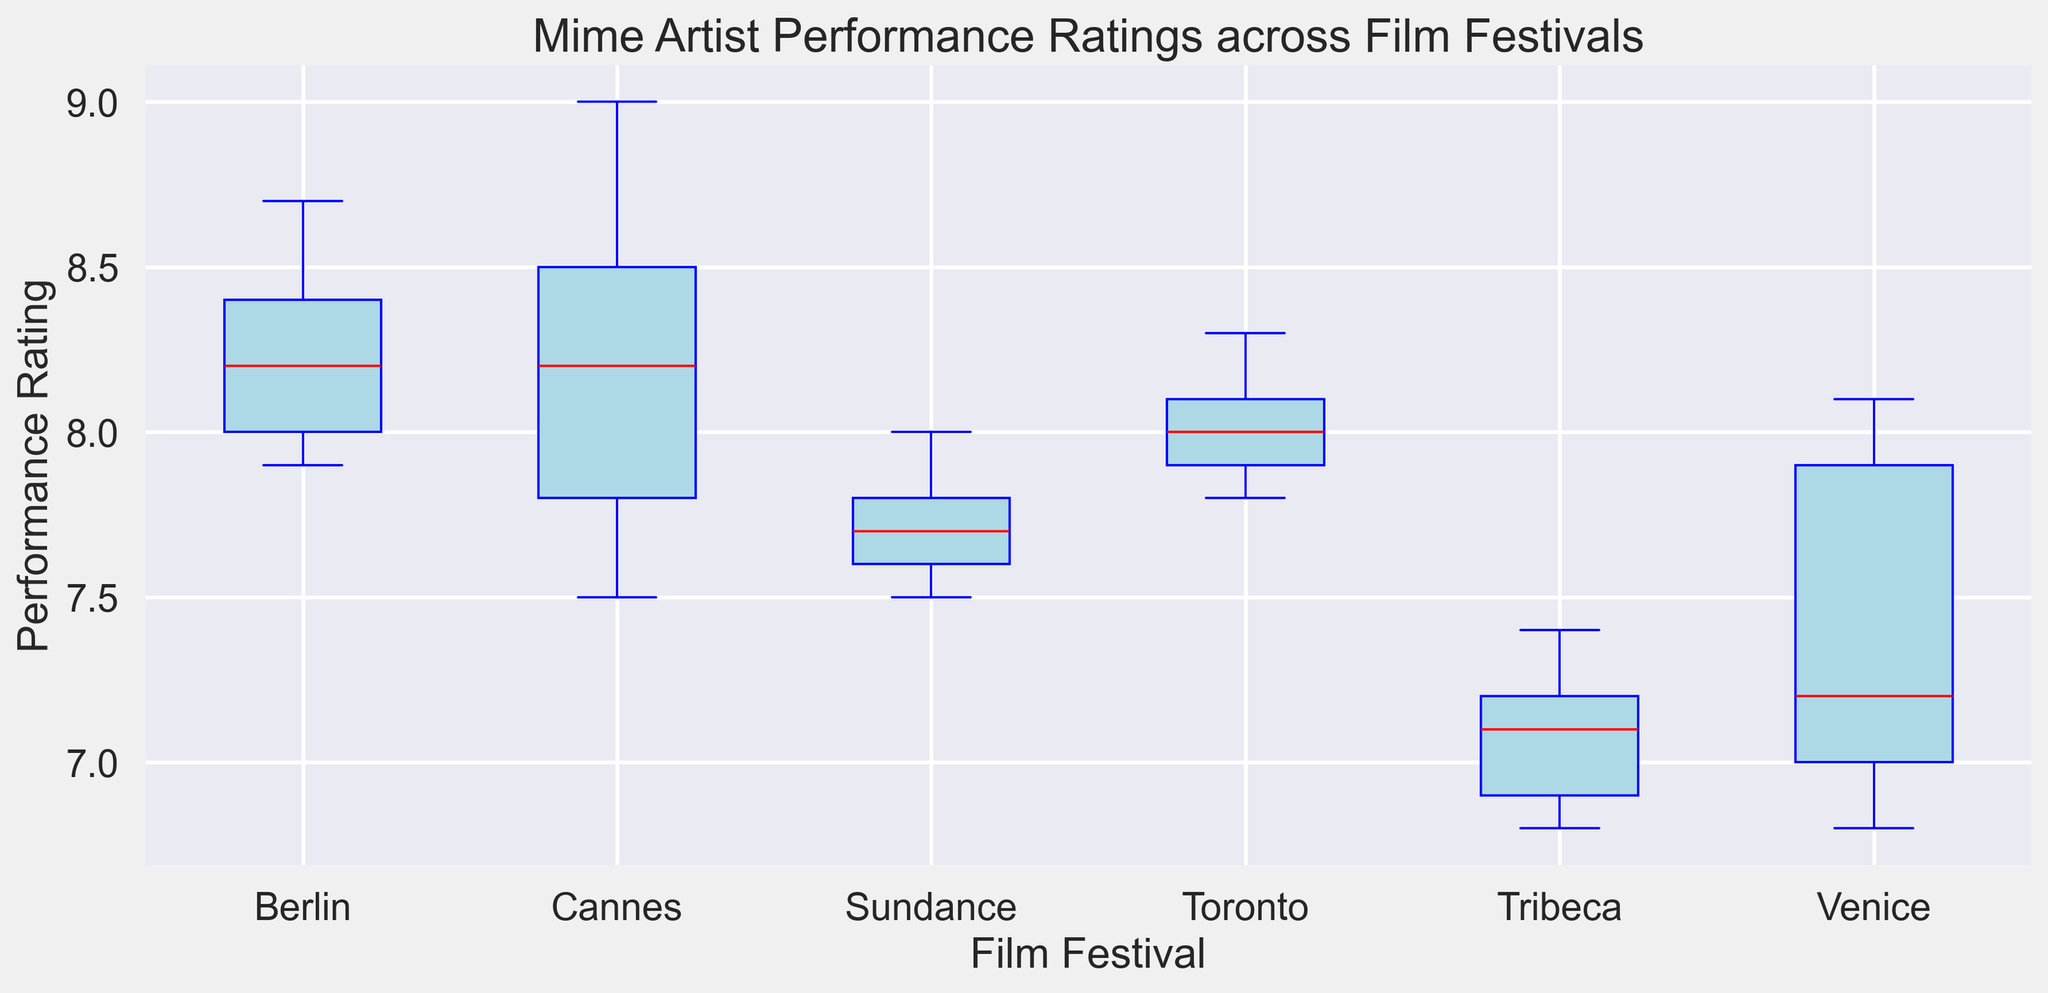What is the median Performance Rating at the Cannes Film Festival? Look at the box plot for the Cannes Film Festival and identify the median line (red) within the box.
Answer: 8.2 Which Film Festival has the highest median Performance Rating? Compare the median lines (red) for all the film festivals and identify the one with the highest position.
Answer: Cannes Which two Film Festivals have the greatest difference in their median Performance Ratings? Identify the median lines for all the festivals. Find the two with the highest and lowest medians and calculate their difference.
Answer: Cannes and Tribeca What is the range (difference between the maximum and minimum) of Performance Ratings at the Berlin Film Festival? Find the highest and lowest points (whiskers) for the Berlin Film Festival box plot, then compute their difference.
Answer: 8.7 - 7.9 = 0.8 Which Film Festival has the widest interquartile range (IQR, the length of the box)? Compare the lengths of the boxes (the distance between the top and bottom of the boxes) for all the film festivals.
Answer: Venice Between the Toronto and Berlin Film Festivals, which one has a wider range of Performance Ratings? Compare the lengths of the whiskers (from minimum to maximum) for both Toronto and Berlin Film Festivals.
Answer: Toronto What is the outlier Performance Rating for the Venice Film Festival, and how is it visually represented? Identify the red marker (outlier) in the Venice Film Festival box plot and note its position.
Answer: 6.8, represented by a red circle Is there any Film Festival with no visible outliers in Performance Ratings? If so, which one(s)? Check all the box plots and identify any that lack red circle markers outside the whiskers.
Answer: Sundance, Toronto, Cannes Among Cannes, Venice, and Berlin, which Film Festival has the lowest minimum Performance Rating? Compare the lowest points (bottom whiskers) for Cannes, Venice, and Berlin.
Answer: Venice What can we infer about the consistency of Performance Ratings at the Tribeca Film Festival compared to others? Look at the box plot's height (whiskers-to-whisker span) and compare it with the others; shorter span implies more consistency.
Answer: Less consistent 